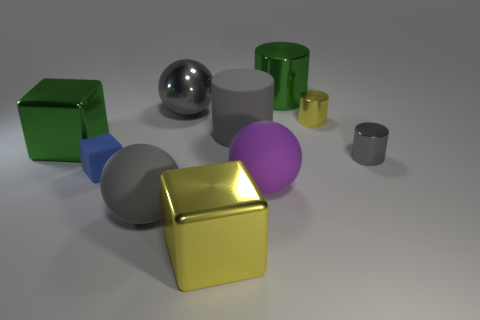What number of other objects are there of the same size as the blue rubber object?
Provide a succinct answer. 2. How many gray objects are both to the left of the green metal cylinder and to the right of the yellow metallic block?
Offer a very short reply. 1. Are the yellow object that is in front of the green cube and the tiny block made of the same material?
Keep it short and to the point. No. There is a big thing that is in front of the gray ball in front of the yellow object that is to the right of the large shiny cylinder; what shape is it?
Keep it short and to the point. Cube. Are there an equal number of small blue blocks that are in front of the blue rubber cube and tiny yellow metal cylinders that are in front of the big gray metallic sphere?
Ensure brevity in your answer.  No. What is the color of the shiny cylinder that is the same size as the gray matte sphere?
Your answer should be very brief. Green. What number of large objects are brown cylinders or blue rubber things?
Ensure brevity in your answer.  0. There is a object that is both in front of the large matte cylinder and on the right side of the large green metal cylinder; what is it made of?
Provide a short and direct response. Metal. There is a large shiny object to the left of the tiny blue matte object; is its shape the same as the yellow metal object on the left side of the green metal cylinder?
Give a very brief answer. Yes. There is a big metallic thing that is the same color as the rubber cylinder; what is its shape?
Make the answer very short. Sphere. 